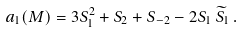<formula> <loc_0><loc_0><loc_500><loc_500>a _ { 1 } ( M ) = 3 S _ { 1 } ^ { 2 } + S _ { 2 } + S _ { - 2 } - 2 S _ { 1 } \, \widetilde { S } _ { 1 } \, .</formula> 